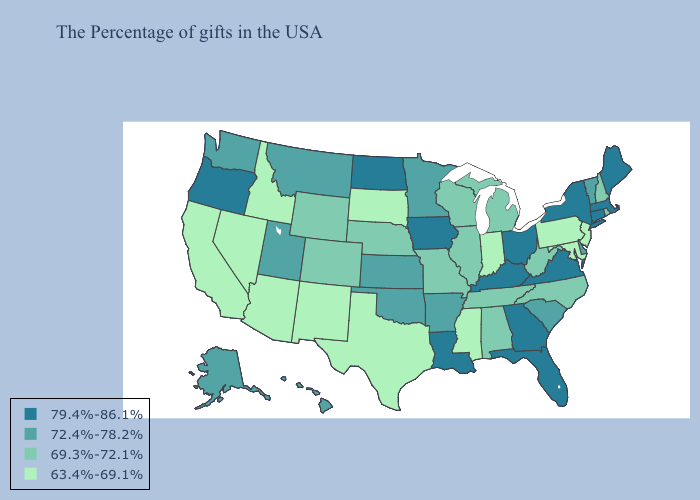Does the map have missing data?
Concise answer only. No. Name the states that have a value in the range 79.4%-86.1%?
Quick response, please. Maine, Massachusetts, Connecticut, New York, Virginia, Ohio, Florida, Georgia, Kentucky, Louisiana, Iowa, North Dakota, Oregon. Which states have the lowest value in the USA?
Give a very brief answer. New Jersey, Maryland, Pennsylvania, Indiana, Mississippi, Texas, South Dakota, New Mexico, Arizona, Idaho, Nevada, California. What is the highest value in the Northeast ?
Be succinct. 79.4%-86.1%. Does Michigan have a lower value than Kansas?
Short answer required. Yes. Does the first symbol in the legend represent the smallest category?
Answer briefly. No. Name the states that have a value in the range 72.4%-78.2%?
Answer briefly. Vermont, Delaware, South Carolina, Arkansas, Minnesota, Kansas, Oklahoma, Utah, Montana, Washington, Alaska, Hawaii. Among the states that border Texas , which have the highest value?
Keep it brief. Louisiana. What is the lowest value in the West?
Concise answer only. 63.4%-69.1%. What is the lowest value in the USA?
Answer briefly. 63.4%-69.1%. Name the states that have a value in the range 79.4%-86.1%?
Answer briefly. Maine, Massachusetts, Connecticut, New York, Virginia, Ohio, Florida, Georgia, Kentucky, Louisiana, Iowa, North Dakota, Oregon. Name the states that have a value in the range 69.3%-72.1%?
Give a very brief answer. Rhode Island, New Hampshire, North Carolina, West Virginia, Michigan, Alabama, Tennessee, Wisconsin, Illinois, Missouri, Nebraska, Wyoming, Colorado. Name the states that have a value in the range 79.4%-86.1%?
Be succinct. Maine, Massachusetts, Connecticut, New York, Virginia, Ohio, Florida, Georgia, Kentucky, Louisiana, Iowa, North Dakota, Oregon. What is the value of Arizona?
Be succinct. 63.4%-69.1%. What is the value of Washington?
Short answer required. 72.4%-78.2%. 